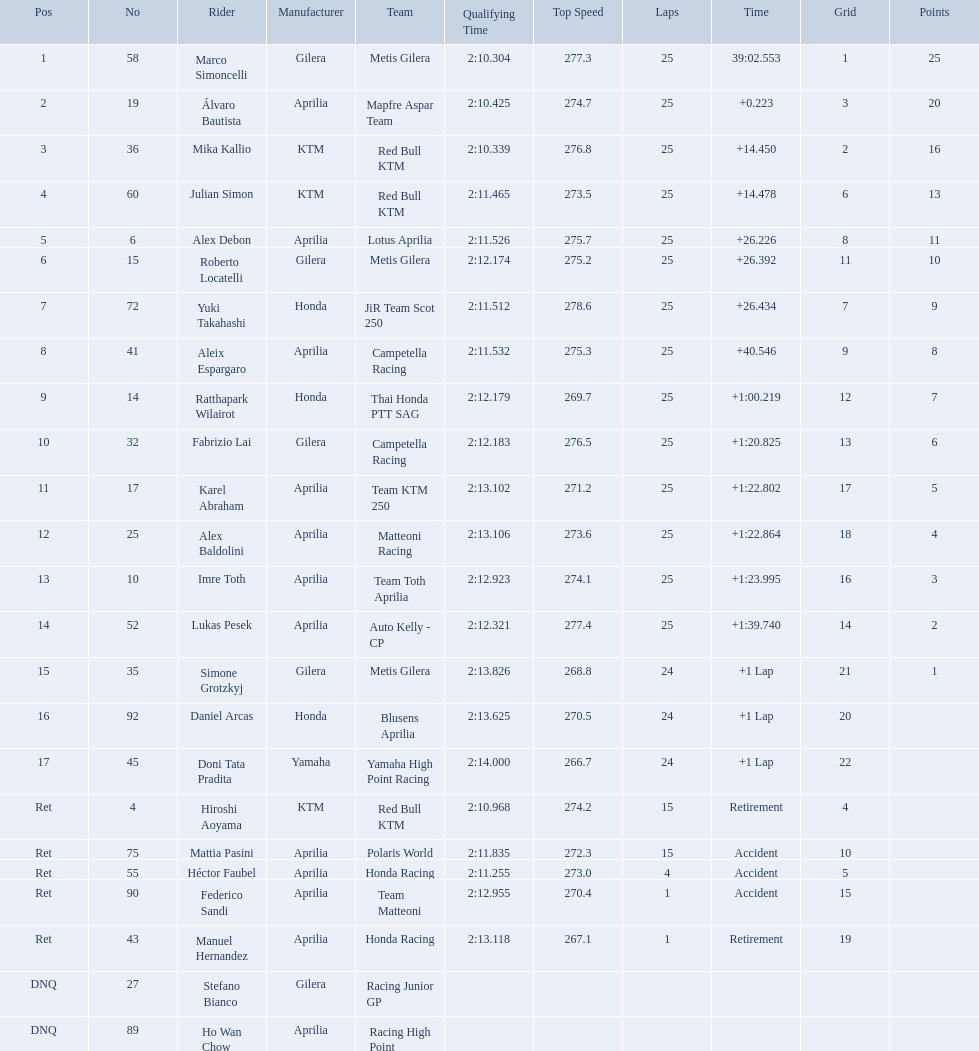How many laps did marco perform? 25. How many laps did hiroshi perform? 15. Which of these numbers are higher? 25. Who swam this number of laps? Marco Simoncelli. Who were all of the riders? Marco Simoncelli, Álvaro Bautista, Mika Kallio, Julian Simon, Alex Debon, Roberto Locatelli, Yuki Takahashi, Aleix Espargaro, Ratthapark Wilairot, Fabrizio Lai, Karel Abraham, Alex Baldolini, Imre Toth, Lukas Pesek, Simone Grotzkyj, Daniel Arcas, Doni Tata Pradita, Hiroshi Aoyama, Mattia Pasini, Héctor Faubel, Federico Sandi, Manuel Hernandez, Stefano Bianco, Ho Wan Chow. How many laps did they complete? 25, 25, 25, 25, 25, 25, 25, 25, 25, 25, 25, 25, 25, 25, 24, 24, 24, 15, 15, 4, 1, 1, , . Between marco simoncelli and hiroshi aoyama, who had more laps? Marco Simoncelli. What player number is marked #1 for the australian motorcycle grand prix? 58. Who is the rider that represents the #58 in the australian motorcycle grand prix? Marco Simoncelli. Who are all the riders? Marco Simoncelli, Álvaro Bautista, Mika Kallio, Julian Simon, Alex Debon, Roberto Locatelli, Yuki Takahashi, Aleix Espargaro, Ratthapark Wilairot, Fabrizio Lai, Karel Abraham, Alex Baldolini, Imre Toth, Lukas Pesek, Simone Grotzkyj, Daniel Arcas, Doni Tata Pradita, Hiroshi Aoyama, Mattia Pasini, Héctor Faubel, Federico Sandi, Manuel Hernandez, Stefano Bianco, Ho Wan Chow. Which held rank 1? Marco Simoncelli. What was the fastest overall time? 39:02.553. Who does this time belong to? Marco Simoncelli. 